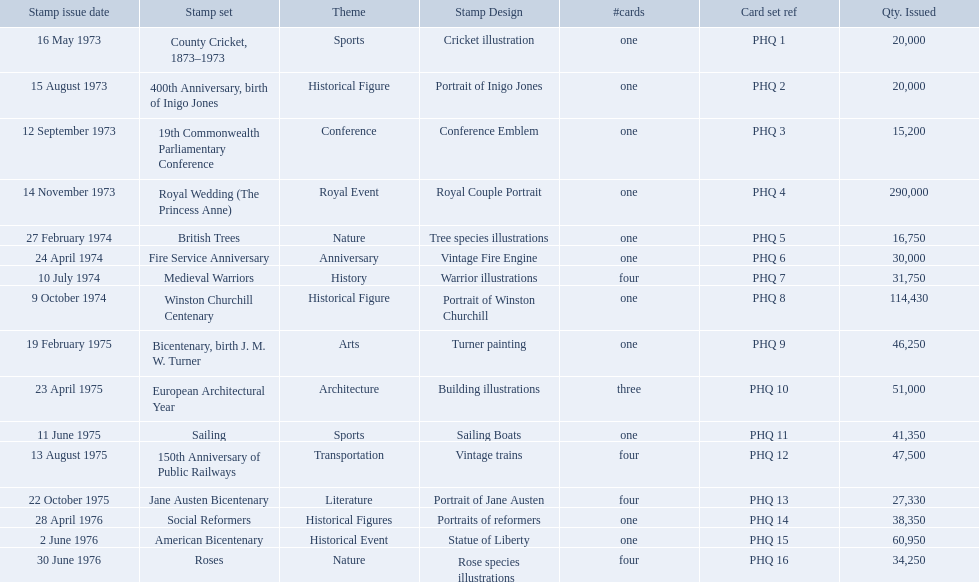Which are the stamp sets in the phq? County Cricket, 1873–1973, 400th Anniversary, birth of Inigo Jones, 19th Commonwealth Parliamentary Conference, Royal Wedding (The Princess Anne), British Trees, Fire Service Anniversary, Medieval Warriors, Winston Churchill Centenary, Bicentenary, birth J. M. W. Turner, European Architectural Year, Sailing, 150th Anniversary of Public Railways, Jane Austen Bicentenary, Social Reformers, American Bicentenary, Roses. Which stamp sets have higher than 200,000 quantity issued? Royal Wedding (The Princess Anne). What are all of the stamp sets? County Cricket, 1873–1973, 400th Anniversary, birth of Inigo Jones, 19th Commonwealth Parliamentary Conference, Royal Wedding (The Princess Anne), British Trees, Fire Service Anniversary, Medieval Warriors, Winston Churchill Centenary, Bicentenary, birth J. M. W. Turner, European Architectural Year, Sailing, 150th Anniversary of Public Railways, Jane Austen Bicentenary, Social Reformers, American Bicentenary, Roses. Which of these sets has three cards in it? European Architectural Year. 